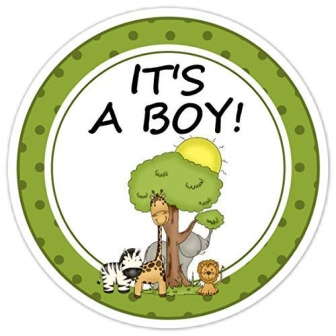What kind of event might this sticker be used for? This sticker is most fitting for a baby shower or a celebration of the birth of a baby boy. Its cheerful animal theme and the colorful, lively setting make it perfect for decorating gifts, invitations, or party favors at a festive gathering where loved ones come together to welcome a new addition to the family. 